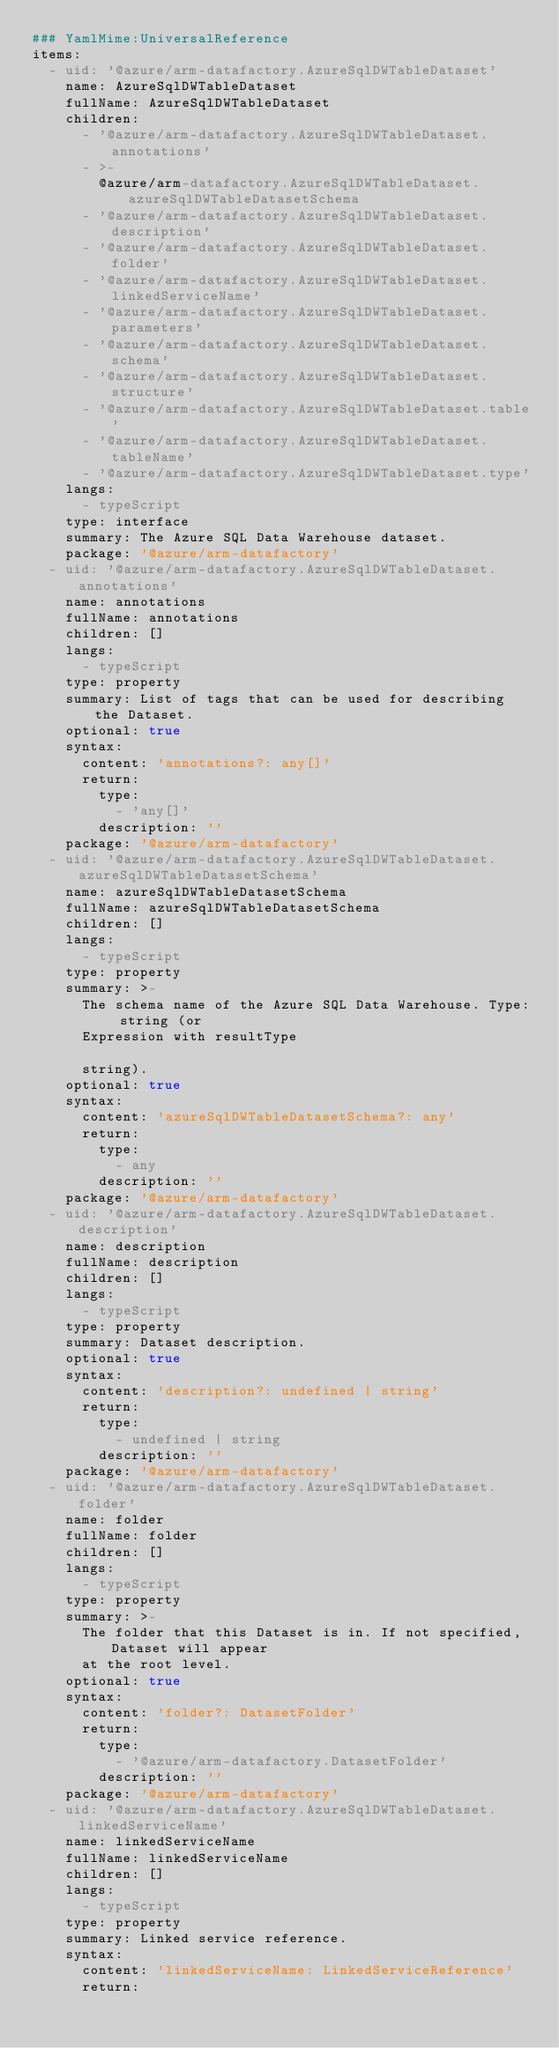<code> <loc_0><loc_0><loc_500><loc_500><_YAML_>### YamlMime:UniversalReference
items:
  - uid: '@azure/arm-datafactory.AzureSqlDWTableDataset'
    name: AzureSqlDWTableDataset
    fullName: AzureSqlDWTableDataset
    children:
      - '@azure/arm-datafactory.AzureSqlDWTableDataset.annotations'
      - >-
        @azure/arm-datafactory.AzureSqlDWTableDataset.azureSqlDWTableDatasetSchema
      - '@azure/arm-datafactory.AzureSqlDWTableDataset.description'
      - '@azure/arm-datafactory.AzureSqlDWTableDataset.folder'
      - '@azure/arm-datafactory.AzureSqlDWTableDataset.linkedServiceName'
      - '@azure/arm-datafactory.AzureSqlDWTableDataset.parameters'
      - '@azure/arm-datafactory.AzureSqlDWTableDataset.schema'
      - '@azure/arm-datafactory.AzureSqlDWTableDataset.structure'
      - '@azure/arm-datafactory.AzureSqlDWTableDataset.table'
      - '@azure/arm-datafactory.AzureSqlDWTableDataset.tableName'
      - '@azure/arm-datafactory.AzureSqlDWTableDataset.type'
    langs:
      - typeScript
    type: interface
    summary: The Azure SQL Data Warehouse dataset.
    package: '@azure/arm-datafactory'
  - uid: '@azure/arm-datafactory.AzureSqlDWTableDataset.annotations'
    name: annotations
    fullName: annotations
    children: []
    langs:
      - typeScript
    type: property
    summary: List of tags that can be used for describing the Dataset.
    optional: true
    syntax:
      content: 'annotations?: any[]'
      return:
        type:
          - 'any[]'
        description: ''
    package: '@azure/arm-datafactory'
  - uid: '@azure/arm-datafactory.AzureSqlDWTableDataset.azureSqlDWTableDatasetSchema'
    name: azureSqlDWTableDatasetSchema
    fullName: azureSqlDWTableDatasetSchema
    children: []
    langs:
      - typeScript
    type: property
    summary: >-
      The schema name of the Azure SQL Data Warehouse. Type: string (or
      Expression with resultType

      string).
    optional: true
    syntax:
      content: 'azureSqlDWTableDatasetSchema?: any'
      return:
        type:
          - any
        description: ''
    package: '@azure/arm-datafactory'
  - uid: '@azure/arm-datafactory.AzureSqlDWTableDataset.description'
    name: description
    fullName: description
    children: []
    langs:
      - typeScript
    type: property
    summary: Dataset description.
    optional: true
    syntax:
      content: 'description?: undefined | string'
      return:
        type:
          - undefined | string
        description: ''
    package: '@azure/arm-datafactory'
  - uid: '@azure/arm-datafactory.AzureSqlDWTableDataset.folder'
    name: folder
    fullName: folder
    children: []
    langs:
      - typeScript
    type: property
    summary: >-
      The folder that this Dataset is in. If not specified, Dataset will appear
      at the root level.
    optional: true
    syntax:
      content: 'folder?: DatasetFolder'
      return:
        type:
          - '@azure/arm-datafactory.DatasetFolder'
        description: ''
    package: '@azure/arm-datafactory'
  - uid: '@azure/arm-datafactory.AzureSqlDWTableDataset.linkedServiceName'
    name: linkedServiceName
    fullName: linkedServiceName
    children: []
    langs:
      - typeScript
    type: property
    summary: Linked service reference.
    syntax:
      content: 'linkedServiceName: LinkedServiceReference'
      return:</code> 